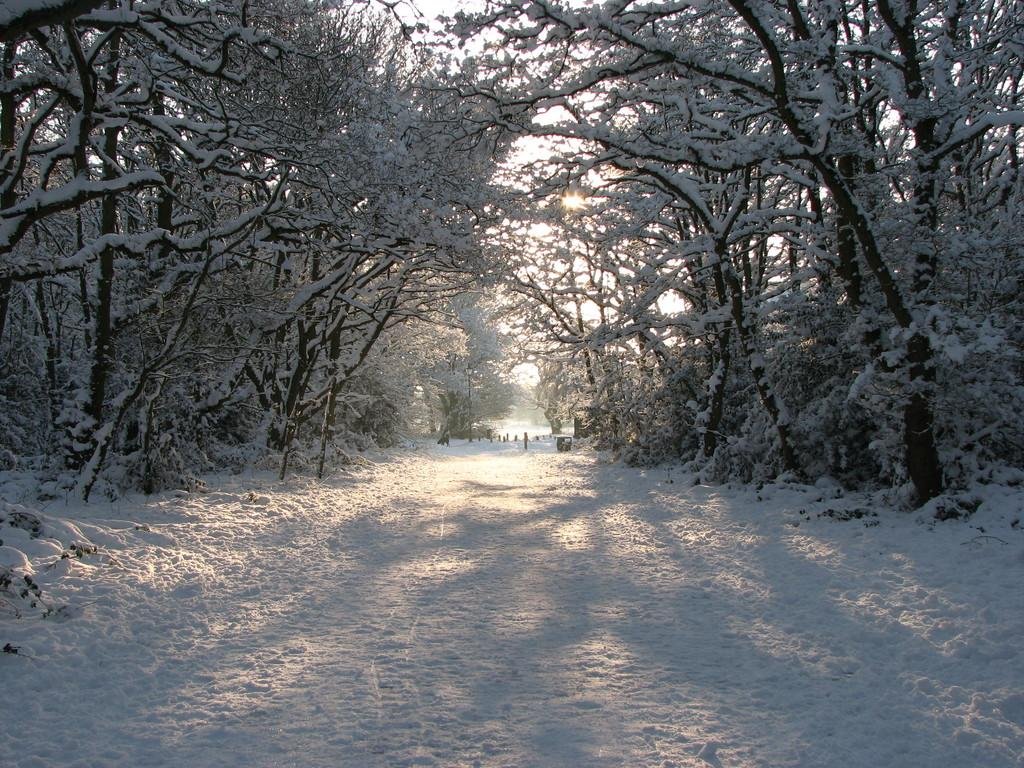What type of weather condition is depicted in the image? There is snow in the image, indicating a cold and wintry scene. What natural elements can be seen in the image? There are trees in the image. What is visible in the background of the image? The sky is visible behind the trees. What color is the ink used to write on the shirt in the image? There is no shirt or ink present in the image; it only features snow and trees. 